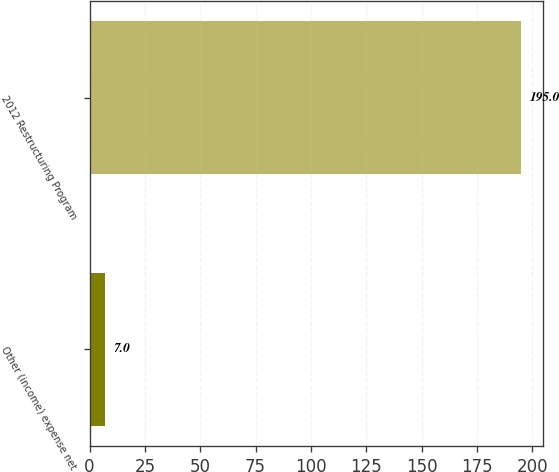Convert chart. <chart><loc_0><loc_0><loc_500><loc_500><bar_chart><fcel>Other (income) expense net<fcel>2012 Restructuring Program<nl><fcel>7<fcel>195<nl></chart> 